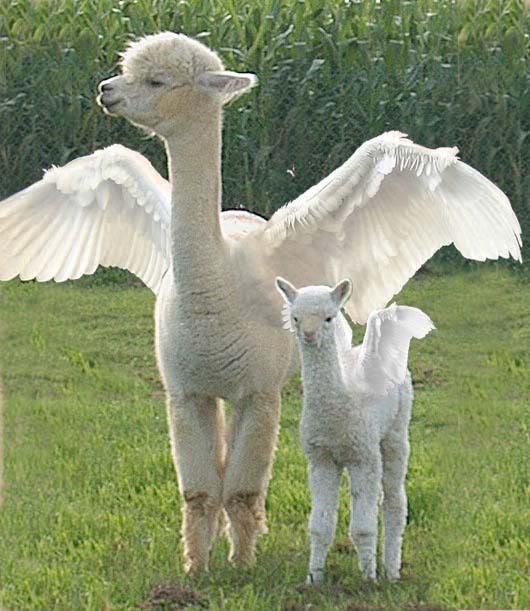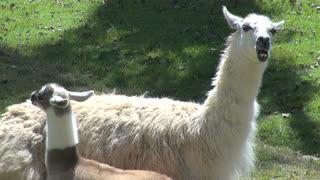The first image is the image on the left, the second image is the image on the right. Assess this claim about the two images: "The llamas in the left image are looking in opposite directions.". Correct or not? Answer yes or no. No. The first image is the image on the left, the second image is the image on the right. Analyze the images presented: Is the assertion "The left image shows a small white llama standing alongside a taller white llama, both with bodies facing forward." valid? Answer yes or no. Yes. 